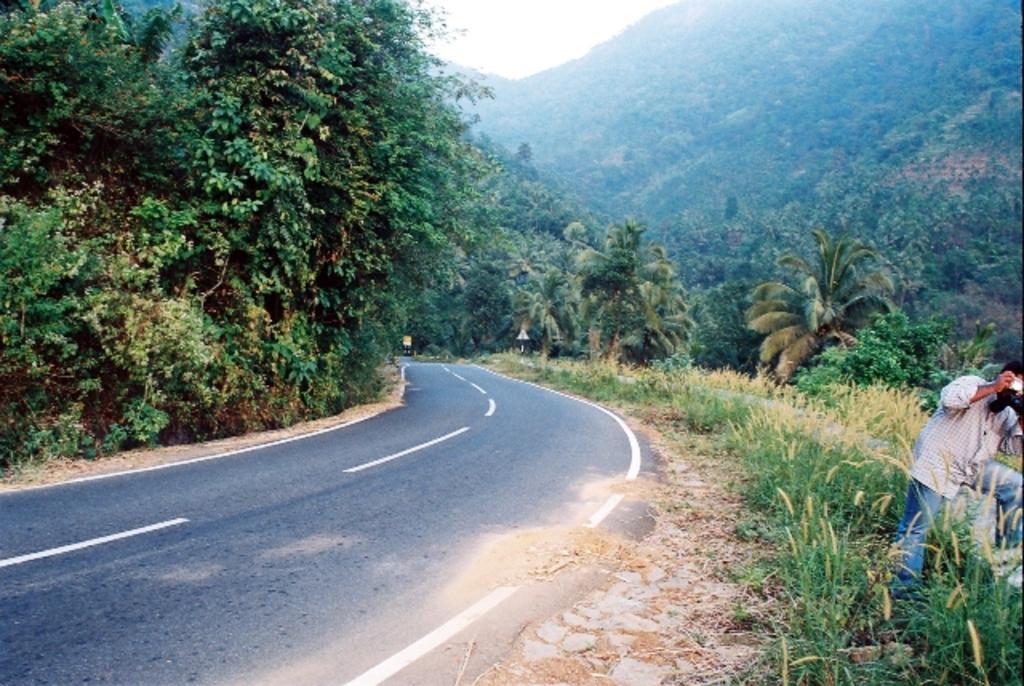How would you summarize this image in a sentence or two? On the right side of the image we can see one person is standing and he is holding a camera. In the background we can see the sky, hills, trees, plants, sign boards, road and a few other objects. 